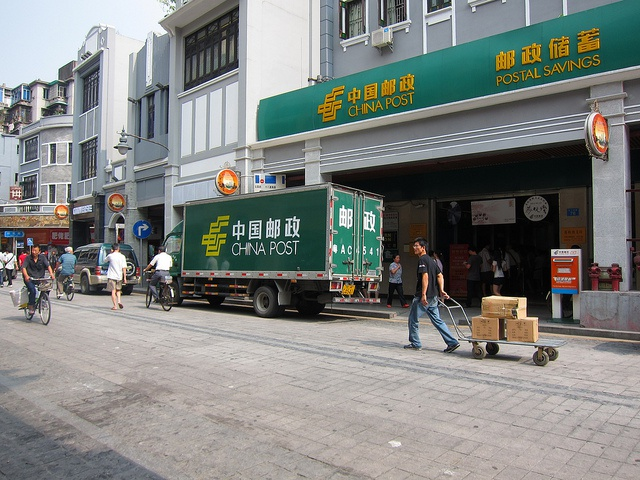Describe the objects in this image and their specific colors. I can see truck in lavender, black, darkgreen, darkgray, and gray tones, people in lavender, black, gray, and blue tones, car in lavender, gray, black, darkgray, and blue tones, people in lavender, black, gray, and brown tones, and people in lavender, white, darkgray, lightpink, and gray tones in this image. 